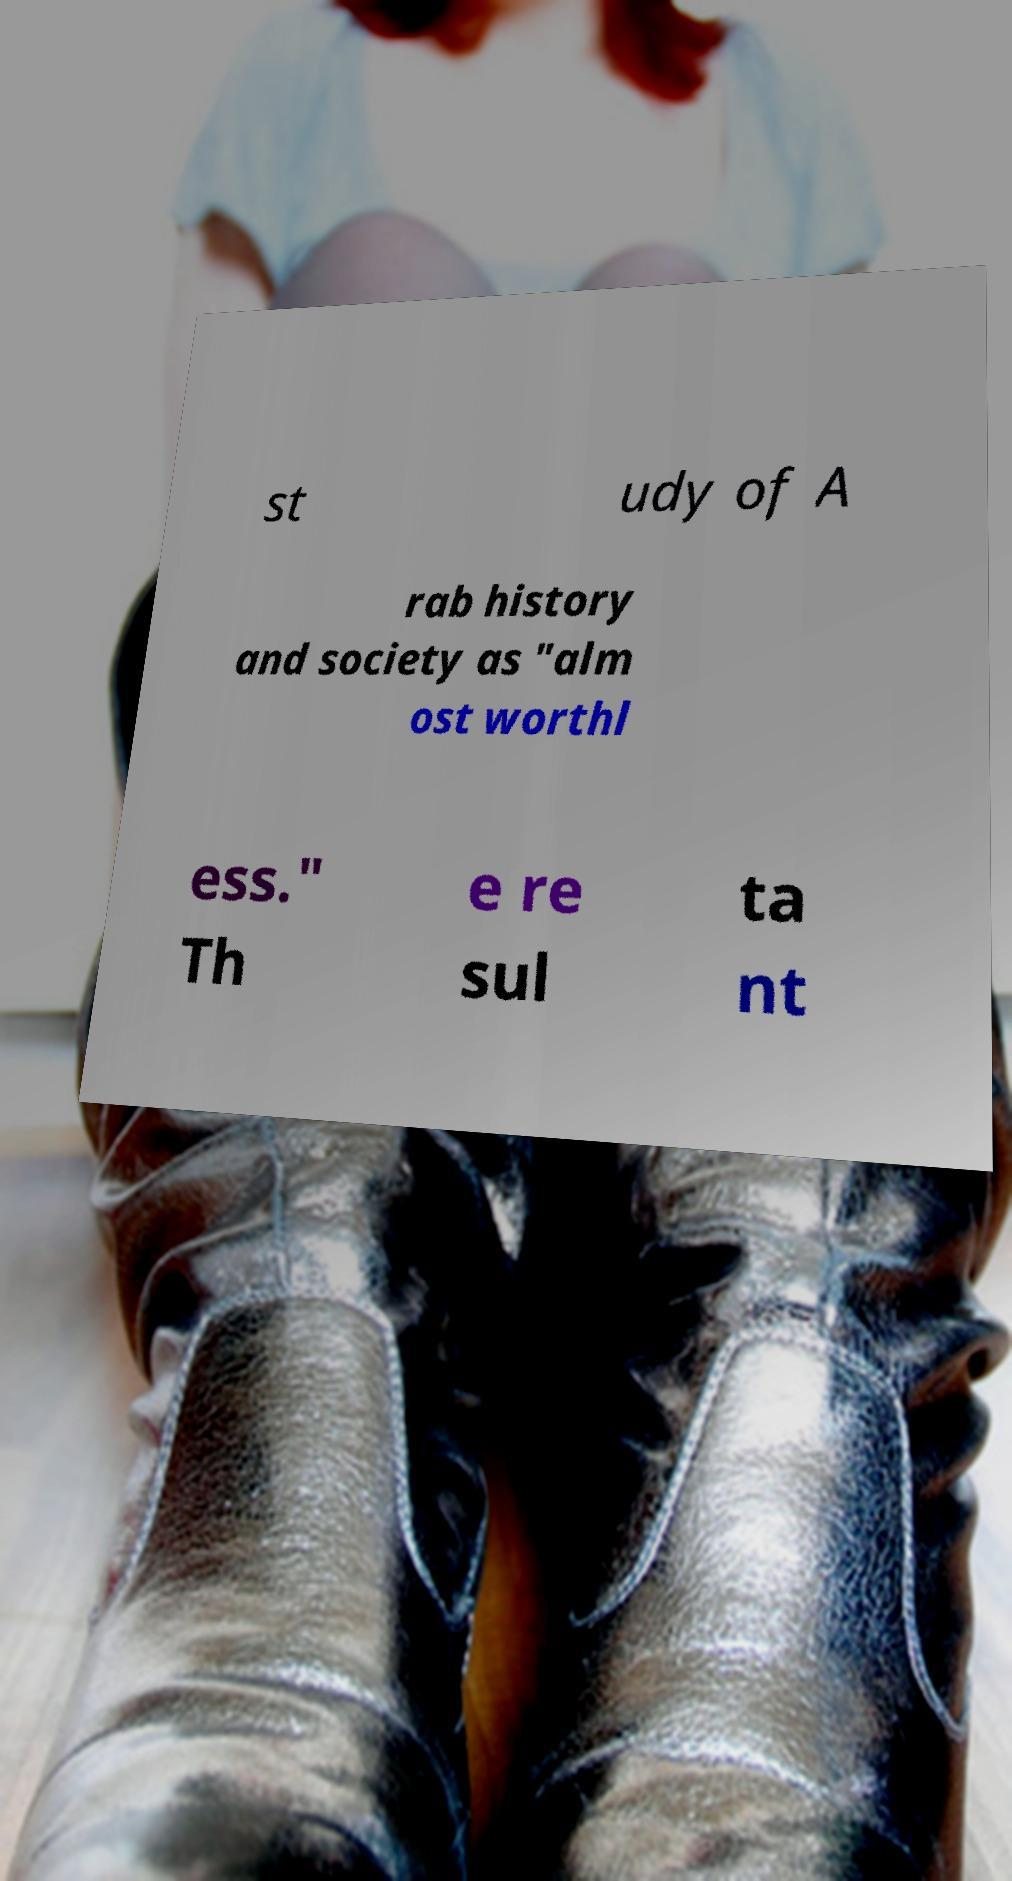I need the written content from this picture converted into text. Can you do that? st udy of A rab history and society as "alm ost worthl ess." Th e re sul ta nt 